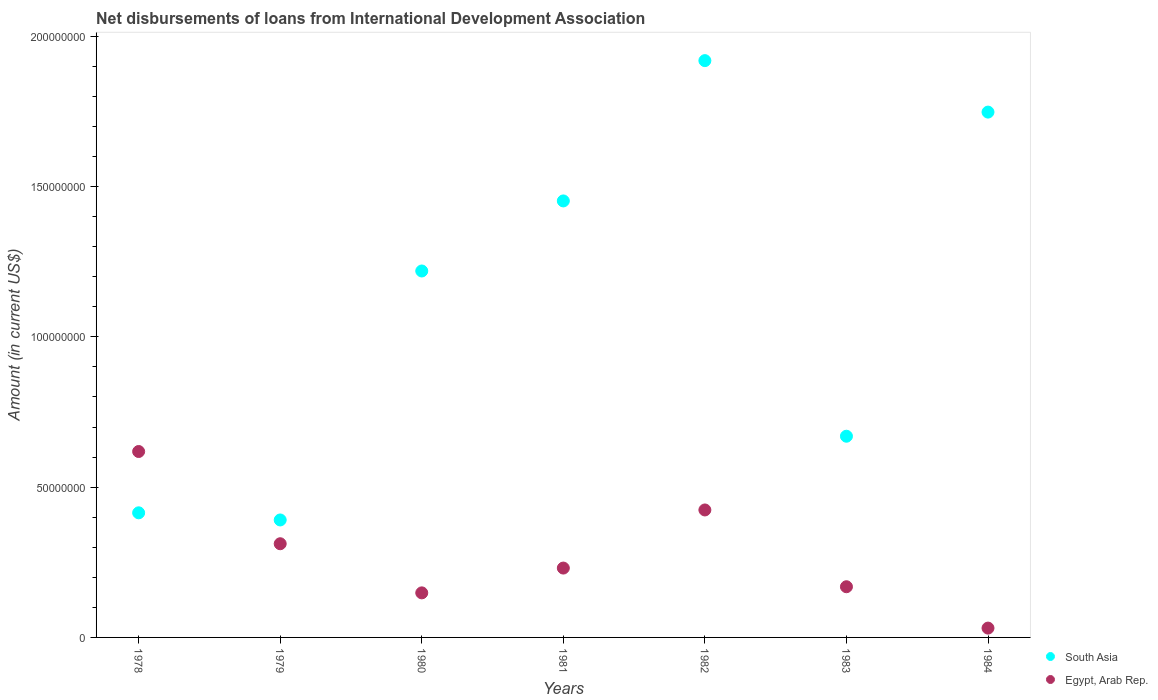How many different coloured dotlines are there?
Give a very brief answer. 2. What is the amount of loans disbursed in Egypt, Arab Rep. in 1982?
Your answer should be compact. 4.24e+07. Across all years, what is the maximum amount of loans disbursed in South Asia?
Keep it short and to the point. 1.92e+08. Across all years, what is the minimum amount of loans disbursed in South Asia?
Keep it short and to the point. 3.91e+07. In which year was the amount of loans disbursed in Egypt, Arab Rep. maximum?
Your answer should be very brief. 1978. In which year was the amount of loans disbursed in South Asia minimum?
Offer a terse response. 1979. What is the total amount of loans disbursed in South Asia in the graph?
Keep it short and to the point. 7.81e+08. What is the difference between the amount of loans disbursed in Egypt, Arab Rep. in 1981 and that in 1983?
Make the answer very short. 6.21e+06. What is the difference between the amount of loans disbursed in South Asia in 1979 and the amount of loans disbursed in Egypt, Arab Rep. in 1978?
Offer a terse response. -2.28e+07. What is the average amount of loans disbursed in Egypt, Arab Rep. per year?
Provide a succinct answer. 2.76e+07. In the year 1982, what is the difference between the amount of loans disbursed in South Asia and amount of loans disbursed in Egypt, Arab Rep.?
Provide a succinct answer. 1.50e+08. In how many years, is the amount of loans disbursed in Egypt, Arab Rep. greater than 70000000 US$?
Provide a succinct answer. 0. What is the ratio of the amount of loans disbursed in South Asia in 1978 to that in 1982?
Your answer should be very brief. 0.22. What is the difference between the highest and the second highest amount of loans disbursed in South Asia?
Give a very brief answer. 1.71e+07. What is the difference between the highest and the lowest amount of loans disbursed in Egypt, Arab Rep.?
Your answer should be compact. 5.88e+07. Is the sum of the amount of loans disbursed in Egypt, Arab Rep. in 1978 and 1979 greater than the maximum amount of loans disbursed in South Asia across all years?
Offer a terse response. No. How many dotlines are there?
Your answer should be compact. 2. How many years are there in the graph?
Offer a terse response. 7. What is the difference between two consecutive major ticks on the Y-axis?
Offer a very short reply. 5.00e+07. Are the values on the major ticks of Y-axis written in scientific E-notation?
Your response must be concise. No. Does the graph contain grids?
Ensure brevity in your answer.  No. Where does the legend appear in the graph?
Give a very brief answer. Bottom right. What is the title of the graph?
Give a very brief answer. Net disbursements of loans from International Development Association. What is the Amount (in current US$) of South Asia in 1978?
Offer a terse response. 4.15e+07. What is the Amount (in current US$) of Egypt, Arab Rep. in 1978?
Offer a terse response. 6.19e+07. What is the Amount (in current US$) in South Asia in 1979?
Provide a short and direct response. 3.91e+07. What is the Amount (in current US$) of Egypt, Arab Rep. in 1979?
Give a very brief answer. 3.12e+07. What is the Amount (in current US$) of South Asia in 1980?
Give a very brief answer. 1.22e+08. What is the Amount (in current US$) of Egypt, Arab Rep. in 1980?
Ensure brevity in your answer.  1.48e+07. What is the Amount (in current US$) of South Asia in 1981?
Keep it short and to the point. 1.45e+08. What is the Amount (in current US$) of Egypt, Arab Rep. in 1981?
Offer a very short reply. 2.31e+07. What is the Amount (in current US$) of South Asia in 1982?
Your response must be concise. 1.92e+08. What is the Amount (in current US$) in Egypt, Arab Rep. in 1982?
Offer a terse response. 4.24e+07. What is the Amount (in current US$) of South Asia in 1983?
Keep it short and to the point. 6.69e+07. What is the Amount (in current US$) of Egypt, Arab Rep. in 1983?
Your answer should be very brief. 1.69e+07. What is the Amount (in current US$) of South Asia in 1984?
Provide a short and direct response. 1.75e+08. What is the Amount (in current US$) of Egypt, Arab Rep. in 1984?
Give a very brief answer. 3.10e+06. Across all years, what is the maximum Amount (in current US$) of South Asia?
Keep it short and to the point. 1.92e+08. Across all years, what is the maximum Amount (in current US$) in Egypt, Arab Rep.?
Give a very brief answer. 6.19e+07. Across all years, what is the minimum Amount (in current US$) of South Asia?
Your answer should be very brief. 3.91e+07. Across all years, what is the minimum Amount (in current US$) in Egypt, Arab Rep.?
Give a very brief answer. 3.10e+06. What is the total Amount (in current US$) of South Asia in the graph?
Your response must be concise. 7.81e+08. What is the total Amount (in current US$) in Egypt, Arab Rep. in the graph?
Offer a very short reply. 1.93e+08. What is the difference between the Amount (in current US$) in South Asia in 1978 and that in 1979?
Your answer should be compact. 2.37e+06. What is the difference between the Amount (in current US$) in Egypt, Arab Rep. in 1978 and that in 1979?
Your answer should be compact. 3.07e+07. What is the difference between the Amount (in current US$) in South Asia in 1978 and that in 1980?
Offer a very short reply. -8.05e+07. What is the difference between the Amount (in current US$) in Egypt, Arab Rep. in 1978 and that in 1980?
Ensure brevity in your answer.  4.70e+07. What is the difference between the Amount (in current US$) of South Asia in 1978 and that in 1981?
Make the answer very short. -1.04e+08. What is the difference between the Amount (in current US$) in Egypt, Arab Rep. in 1978 and that in 1981?
Ensure brevity in your answer.  3.88e+07. What is the difference between the Amount (in current US$) in South Asia in 1978 and that in 1982?
Keep it short and to the point. -1.50e+08. What is the difference between the Amount (in current US$) in Egypt, Arab Rep. in 1978 and that in 1982?
Ensure brevity in your answer.  1.94e+07. What is the difference between the Amount (in current US$) in South Asia in 1978 and that in 1983?
Keep it short and to the point. -2.55e+07. What is the difference between the Amount (in current US$) in Egypt, Arab Rep. in 1978 and that in 1983?
Your answer should be compact. 4.50e+07. What is the difference between the Amount (in current US$) in South Asia in 1978 and that in 1984?
Ensure brevity in your answer.  -1.33e+08. What is the difference between the Amount (in current US$) of Egypt, Arab Rep. in 1978 and that in 1984?
Ensure brevity in your answer.  5.88e+07. What is the difference between the Amount (in current US$) in South Asia in 1979 and that in 1980?
Make the answer very short. -8.28e+07. What is the difference between the Amount (in current US$) of Egypt, Arab Rep. in 1979 and that in 1980?
Give a very brief answer. 1.63e+07. What is the difference between the Amount (in current US$) of South Asia in 1979 and that in 1981?
Your response must be concise. -1.06e+08. What is the difference between the Amount (in current US$) of Egypt, Arab Rep. in 1979 and that in 1981?
Your answer should be compact. 8.09e+06. What is the difference between the Amount (in current US$) in South Asia in 1979 and that in 1982?
Your answer should be very brief. -1.53e+08. What is the difference between the Amount (in current US$) in Egypt, Arab Rep. in 1979 and that in 1982?
Make the answer very short. -1.12e+07. What is the difference between the Amount (in current US$) in South Asia in 1979 and that in 1983?
Provide a short and direct response. -2.79e+07. What is the difference between the Amount (in current US$) in Egypt, Arab Rep. in 1979 and that in 1983?
Make the answer very short. 1.43e+07. What is the difference between the Amount (in current US$) of South Asia in 1979 and that in 1984?
Your response must be concise. -1.36e+08. What is the difference between the Amount (in current US$) of Egypt, Arab Rep. in 1979 and that in 1984?
Your answer should be compact. 2.81e+07. What is the difference between the Amount (in current US$) of South Asia in 1980 and that in 1981?
Your answer should be compact. -2.33e+07. What is the difference between the Amount (in current US$) of Egypt, Arab Rep. in 1980 and that in 1981?
Give a very brief answer. -8.25e+06. What is the difference between the Amount (in current US$) in South Asia in 1980 and that in 1982?
Make the answer very short. -7.00e+07. What is the difference between the Amount (in current US$) in Egypt, Arab Rep. in 1980 and that in 1982?
Provide a short and direct response. -2.76e+07. What is the difference between the Amount (in current US$) of South Asia in 1980 and that in 1983?
Keep it short and to the point. 5.50e+07. What is the difference between the Amount (in current US$) in Egypt, Arab Rep. in 1980 and that in 1983?
Provide a short and direct response. -2.04e+06. What is the difference between the Amount (in current US$) of South Asia in 1980 and that in 1984?
Your response must be concise. -5.29e+07. What is the difference between the Amount (in current US$) in Egypt, Arab Rep. in 1980 and that in 1984?
Provide a short and direct response. 1.17e+07. What is the difference between the Amount (in current US$) of South Asia in 1981 and that in 1982?
Offer a terse response. -4.67e+07. What is the difference between the Amount (in current US$) of Egypt, Arab Rep. in 1981 and that in 1982?
Provide a succinct answer. -1.93e+07. What is the difference between the Amount (in current US$) in South Asia in 1981 and that in 1983?
Provide a short and direct response. 7.83e+07. What is the difference between the Amount (in current US$) of Egypt, Arab Rep. in 1981 and that in 1983?
Provide a short and direct response. 6.21e+06. What is the difference between the Amount (in current US$) in South Asia in 1981 and that in 1984?
Provide a succinct answer. -2.96e+07. What is the difference between the Amount (in current US$) of Egypt, Arab Rep. in 1981 and that in 1984?
Your answer should be compact. 2.00e+07. What is the difference between the Amount (in current US$) of South Asia in 1982 and that in 1983?
Your answer should be compact. 1.25e+08. What is the difference between the Amount (in current US$) of Egypt, Arab Rep. in 1982 and that in 1983?
Make the answer very short. 2.55e+07. What is the difference between the Amount (in current US$) in South Asia in 1982 and that in 1984?
Offer a terse response. 1.71e+07. What is the difference between the Amount (in current US$) of Egypt, Arab Rep. in 1982 and that in 1984?
Your answer should be compact. 3.93e+07. What is the difference between the Amount (in current US$) of South Asia in 1983 and that in 1984?
Your response must be concise. -1.08e+08. What is the difference between the Amount (in current US$) in Egypt, Arab Rep. in 1983 and that in 1984?
Keep it short and to the point. 1.38e+07. What is the difference between the Amount (in current US$) in South Asia in 1978 and the Amount (in current US$) in Egypt, Arab Rep. in 1979?
Your response must be concise. 1.03e+07. What is the difference between the Amount (in current US$) of South Asia in 1978 and the Amount (in current US$) of Egypt, Arab Rep. in 1980?
Provide a short and direct response. 2.66e+07. What is the difference between the Amount (in current US$) of South Asia in 1978 and the Amount (in current US$) of Egypt, Arab Rep. in 1981?
Make the answer very short. 1.84e+07. What is the difference between the Amount (in current US$) of South Asia in 1978 and the Amount (in current US$) of Egypt, Arab Rep. in 1982?
Offer a very short reply. -9.53e+05. What is the difference between the Amount (in current US$) in South Asia in 1978 and the Amount (in current US$) in Egypt, Arab Rep. in 1983?
Offer a very short reply. 2.46e+07. What is the difference between the Amount (in current US$) in South Asia in 1978 and the Amount (in current US$) in Egypt, Arab Rep. in 1984?
Provide a short and direct response. 3.84e+07. What is the difference between the Amount (in current US$) in South Asia in 1979 and the Amount (in current US$) in Egypt, Arab Rep. in 1980?
Offer a very short reply. 2.43e+07. What is the difference between the Amount (in current US$) of South Asia in 1979 and the Amount (in current US$) of Egypt, Arab Rep. in 1981?
Your answer should be very brief. 1.60e+07. What is the difference between the Amount (in current US$) in South Asia in 1979 and the Amount (in current US$) in Egypt, Arab Rep. in 1982?
Give a very brief answer. -3.33e+06. What is the difference between the Amount (in current US$) in South Asia in 1979 and the Amount (in current US$) in Egypt, Arab Rep. in 1983?
Your answer should be compact. 2.22e+07. What is the difference between the Amount (in current US$) in South Asia in 1979 and the Amount (in current US$) in Egypt, Arab Rep. in 1984?
Ensure brevity in your answer.  3.60e+07. What is the difference between the Amount (in current US$) of South Asia in 1980 and the Amount (in current US$) of Egypt, Arab Rep. in 1981?
Provide a short and direct response. 9.88e+07. What is the difference between the Amount (in current US$) in South Asia in 1980 and the Amount (in current US$) in Egypt, Arab Rep. in 1982?
Provide a short and direct response. 7.95e+07. What is the difference between the Amount (in current US$) in South Asia in 1980 and the Amount (in current US$) in Egypt, Arab Rep. in 1983?
Provide a short and direct response. 1.05e+08. What is the difference between the Amount (in current US$) of South Asia in 1980 and the Amount (in current US$) of Egypt, Arab Rep. in 1984?
Provide a succinct answer. 1.19e+08. What is the difference between the Amount (in current US$) in South Asia in 1981 and the Amount (in current US$) in Egypt, Arab Rep. in 1982?
Your answer should be compact. 1.03e+08. What is the difference between the Amount (in current US$) of South Asia in 1981 and the Amount (in current US$) of Egypt, Arab Rep. in 1983?
Your answer should be compact. 1.28e+08. What is the difference between the Amount (in current US$) of South Asia in 1981 and the Amount (in current US$) of Egypt, Arab Rep. in 1984?
Offer a terse response. 1.42e+08. What is the difference between the Amount (in current US$) in South Asia in 1982 and the Amount (in current US$) in Egypt, Arab Rep. in 1983?
Offer a very short reply. 1.75e+08. What is the difference between the Amount (in current US$) in South Asia in 1982 and the Amount (in current US$) in Egypt, Arab Rep. in 1984?
Provide a succinct answer. 1.89e+08. What is the difference between the Amount (in current US$) in South Asia in 1983 and the Amount (in current US$) in Egypt, Arab Rep. in 1984?
Offer a very short reply. 6.38e+07. What is the average Amount (in current US$) of South Asia per year?
Your answer should be compact. 1.12e+08. What is the average Amount (in current US$) of Egypt, Arab Rep. per year?
Give a very brief answer. 2.76e+07. In the year 1978, what is the difference between the Amount (in current US$) of South Asia and Amount (in current US$) of Egypt, Arab Rep.?
Keep it short and to the point. -2.04e+07. In the year 1979, what is the difference between the Amount (in current US$) of South Asia and Amount (in current US$) of Egypt, Arab Rep.?
Offer a very short reply. 7.91e+06. In the year 1980, what is the difference between the Amount (in current US$) of South Asia and Amount (in current US$) of Egypt, Arab Rep.?
Make the answer very short. 1.07e+08. In the year 1981, what is the difference between the Amount (in current US$) of South Asia and Amount (in current US$) of Egypt, Arab Rep.?
Keep it short and to the point. 1.22e+08. In the year 1982, what is the difference between the Amount (in current US$) in South Asia and Amount (in current US$) in Egypt, Arab Rep.?
Provide a short and direct response. 1.50e+08. In the year 1983, what is the difference between the Amount (in current US$) of South Asia and Amount (in current US$) of Egypt, Arab Rep.?
Your response must be concise. 5.01e+07. In the year 1984, what is the difference between the Amount (in current US$) in South Asia and Amount (in current US$) in Egypt, Arab Rep.?
Make the answer very short. 1.72e+08. What is the ratio of the Amount (in current US$) in South Asia in 1978 to that in 1979?
Provide a succinct answer. 1.06. What is the ratio of the Amount (in current US$) in Egypt, Arab Rep. in 1978 to that in 1979?
Keep it short and to the point. 1.98. What is the ratio of the Amount (in current US$) of South Asia in 1978 to that in 1980?
Offer a very short reply. 0.34. What is the ratio of the Amount (in current US$) of Egypt, Arab Rep. in 1978 to that in 1980?
Give a very brief answer. 4.17. What is the ratio of the Amount (in current US$) in South Asia in 1978 to that in 1981?
Make the answer very short. 0.29. What is the ratio of the Amount (in current US$) of Egypt, Arab Rep. in 1978 to that in 1981?
Offer a very short reply. 2.68. What is the ratio of the Amount (in current US$) in South Asia in 1978 to that in 1982?
Offer a terse response. 0.22. What is the ratio of the Amount (in current US$) in Egypt, Arab Rep. in 1978 to that in 1982?
Provide a short and direct response. 1.46. What is the ratio of the Amount (in current US$) of South Asia in 1978 to that in 1983?
Give a very brief answer. 0.62. What is the ratio of the Amount (in current US$) of Egypt, Arab Rep. in 1978 to that in 1983?
Offer a very short reply. 3.67. What is the ratio of the Amount (in current US$) of South Asia in 1978 to that in 1984?
Your answer should be compact. 0.24. What is the ratio of the Amount (in current US$) of Egypt, Arab Rep. in 1978 to that in 1984?
Provide a short and direct response. 19.93. What is the ratio of the Amount (in current US$) in South Asia in 1979 to that in 1980?
Give a very brief answer. 0.32. What is the ratio of the Amount (in current US$) in Egypt, Arab Rep. in 1979 to that in 1980?
Provide a short and direct response. 2.1. What is the ratio of the Amount (in current US$) of South Asia in 1979 to that in 1981?
Your answer should be very brief. 0.27. What is the ratio of the Amount (in current US$) of Egypt, Arab Rep. in 1979 to that in 1981?
Offer a very short reply. 1.35. What is the ratio of the Amount (in current US$) in South Asia in 1979 to that in 1982?
Ensure brevity in your answer.  0.2. What is the ratio of the Amount (in current US$) of Egypt, Arab Rep. in 1979 to that in 1982?
Your answer should be very brief. 0.73. What is the ratio of the Amount (in current US$) of South Asia in 1979 to that in 1983?
Ensure brevity in your answer.  0.58. What is the ratio of the Amount (in current US$) in Egypt, Arab Rep. in 1979 to that in 1983?
Your answer should be very brief. 1.85. What is the ratio of the Amount (in current US$) of South Asia in 1979 to that in 1984?
Your answer should be very brief. 0.22. What is the ratio of the Amount (in current US$) in Egypt, Arab Rep. in 1979 to that in 1984?
Your answer should be very brief. 10.05. What is the ratio of the Amount (in current US$) in South Asia in 1980 to that in 1981?
Offer a terse response. 0.84. What is the ratio of the Amount (in current US$) in Egypt, Arab Rep. in 1980 to that in 1981?
Offer a very short reply. 0.64. What is the ratio of the Amount (in current US$) in South Asia in 1980 to that in 1982?
Make the answer very short. 0.64. What is the ratio of the Amount (in current US$) of Egypt, Arab Rep. in 1980 to that in 1982?
Keep it short and to the point. 0.35. What is the ratio of the Amount (in current US$) in South Asia in 1980 to that in 1983?
Your answer should be very brief. 1.82. What is the ratio of the Amount (in current US$) in Egypt, Arab Rep. in 1980 to that in 1983?
Ensure brevity in your answer.  0.88. What is the ratio of the Amount (in current US$) of South Asia in 1980 to that in 1984?
Provide a succinct answer. 0.7. What is the ratio of the Amount (in current US$) of Egypt, Arab Rep. in 1980 to that in 1984?
Give a very brief answer. 4.78. What is the ratio of the Amount (in current US$) in South Asia in 1981 to that in 1982?
Offer a very short reply. 0.76. What is the ratio of the Amount (in current US$) in Egypt, Arab Rep. in 1981 to that in 1982?
Your answer should be very brief. 0.54. What is the ratio of the Amount (in current US$) of South Asia in 1981 to that in 1983?
Provide a succinct answer. 2.17. What is the ratio of the Amount (in current US$) in Egypt, Arab Rep. in 1981 to that in 1983?
Keep it short and to the point. 1.37. What is the ratio of the Amount (in current US$) of South Asia in 1981 to that in 1984?
Provide a short and direct response. 0.83. What is the ratio of the Amount (in current US$) of Egypt, Arab Rep. in 1981 to that in 1984?
Your answer should be very brief. 7.44. What is the ratio of the Amount (in current US$) of South Asia in 1982 to that in 1983?
Make the answer very short. 2.87. What is the ratio of the Amount (in current US$) of Egypt, Arab Rep. in 1982 to that in 1983?
Your answer should be very brief. 2.51. What is the ratio of the Amount (in current US$) of South Asia in 1982 to that in 1984?
Provide a short and direct response. 1.1. What is the ratio of the Amount (in current US$) in Egypt, Arab Rep. in 1982 to that in 1984?
Your response must be concise. 13.67. What is the ratio of the Amount (in current US$) in South Asia in 1983 to that in 1984?
Make the answer very short. 0.38. What is the ratio of the Amount (in current US$) in Egypt, Arab Rep. in 1983 to that in 1984?
Keep it short and to the point. 5.43. What is the difference between the highest and the second highest Amount (in current US$) in South Asia?
Your answer should be compact. 1.71e+07. What is the difference between the highest and the second highest Amount (in current US$) in Egypt, Arab Rep.?
Your answer should be very brief. 1.94e+07. What is the difference between the highest and the lowest Amount (in current US$) of South Asia?
Offer a terse response. 1.53e+08. What is the difference between the highest and the lowest Amount (in current US$) in Egypt, Arab Rep.?
Your response must be concise. 5.88e+07. 